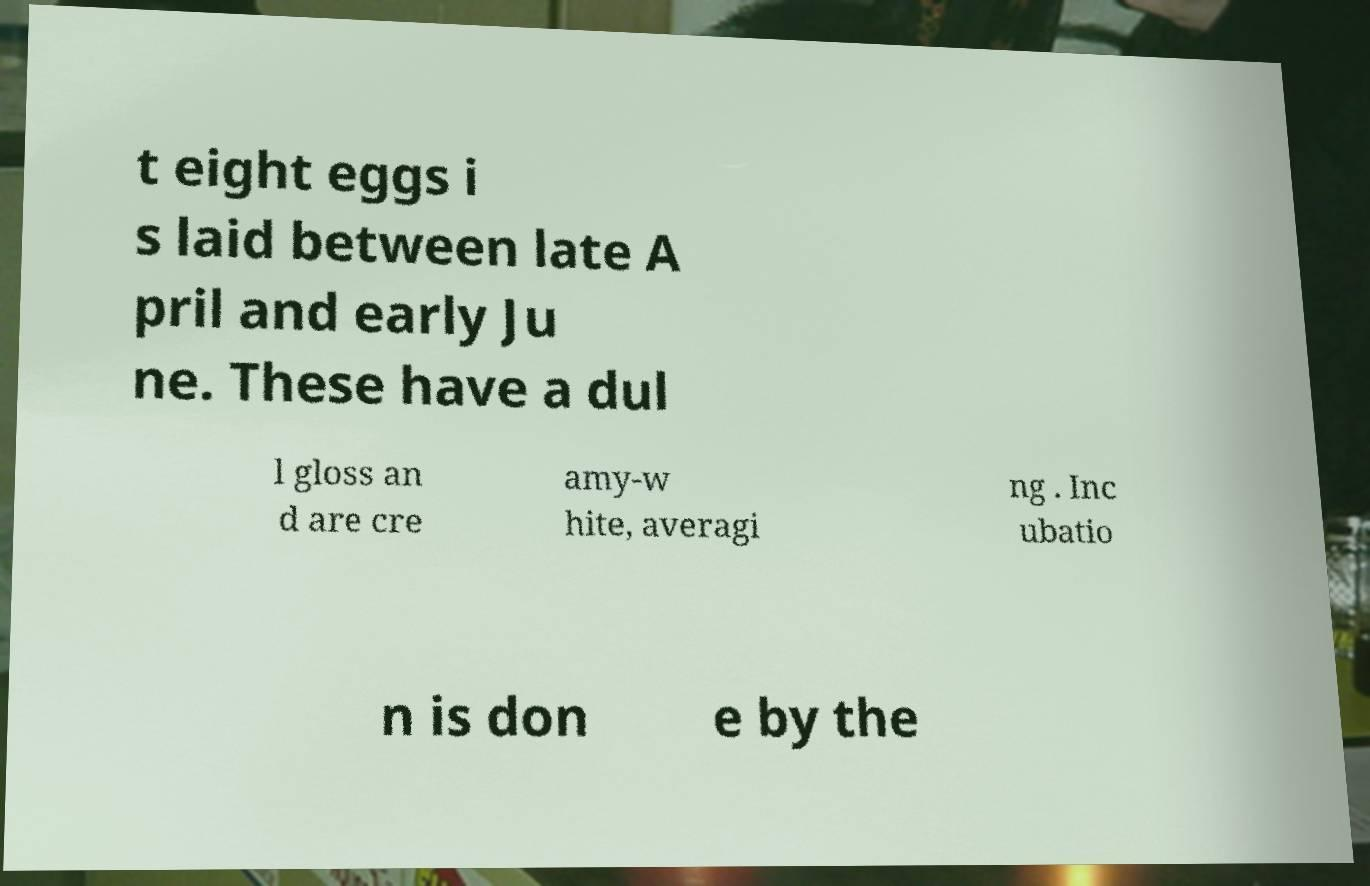Please identify and transcribe the text found in this image. t eight eggs i s laid between late A pril and early Ju ne. These have a dul l gloss an d are cre amy-w hite, averagi ng . Inc ubatio n is don e by the 